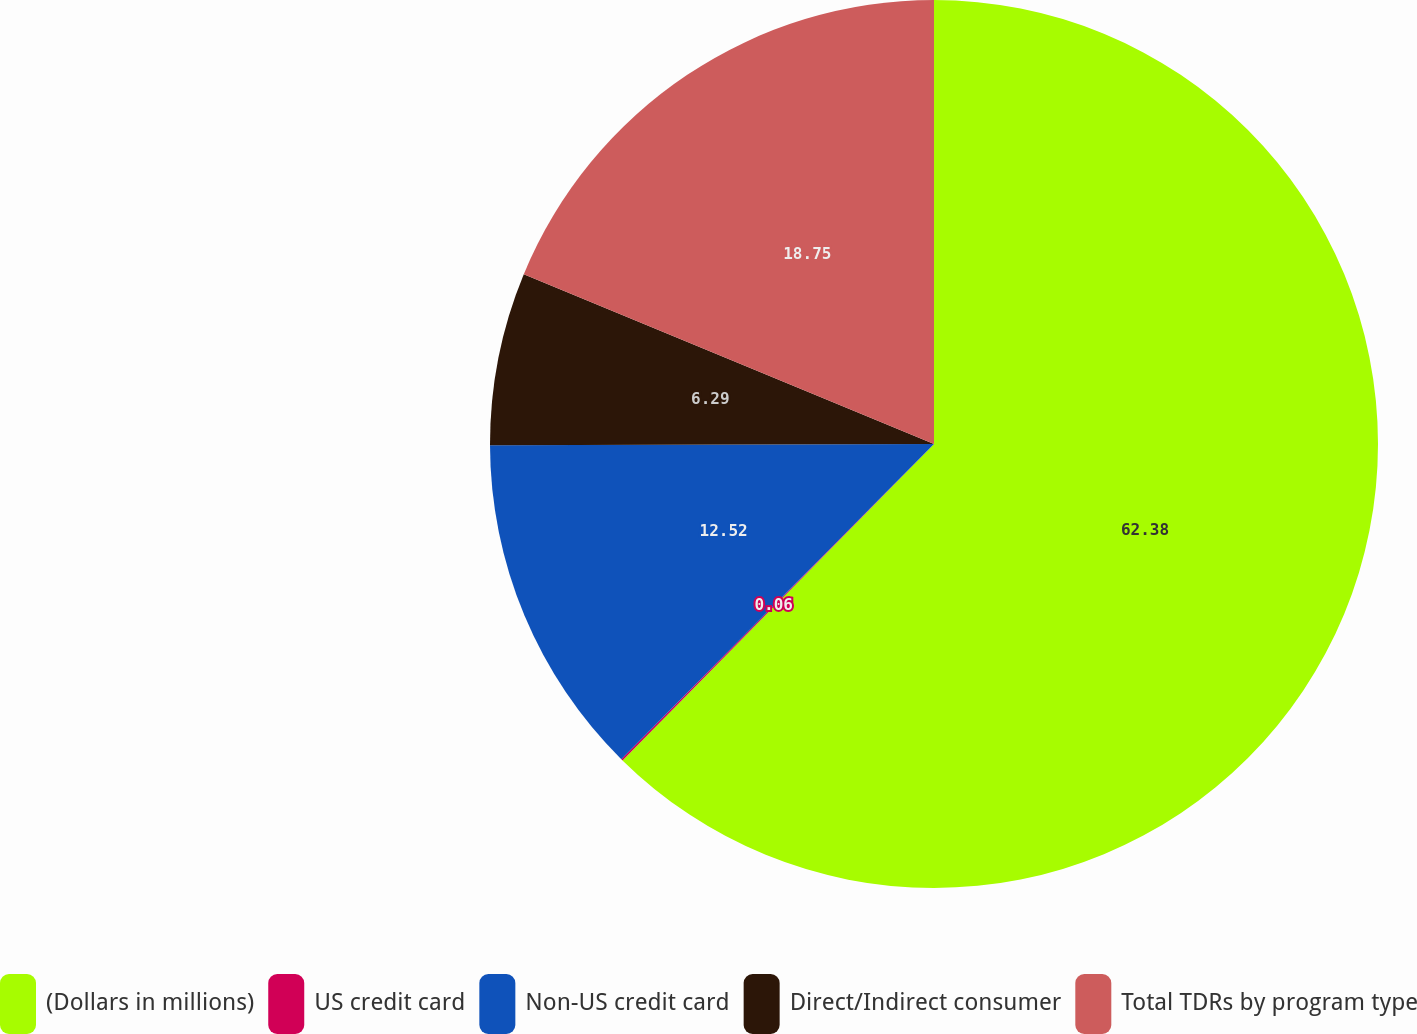<chart> <loc_0><loc_0><loc_500><loc_500><pie_chart><fcel>(Dollars in millions)<fcel>US credit card<fcel>Non-US credit card<fcel>Direct/Indirect consumer<fcel>Total TDRs by program type<nl><fcel>62.37%<fcel>0.06%<fcel>12.52%<fcel>6.29%<fcel>18.75%<nl></chart> 